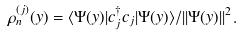<formula> <loc_0><loc_0><loc_500><loc_500>\rho _ { n } ^ { ( j ) } ( y ) = \langle \Psi ( y ) | c _ { j } ^ { \dagger } c _ { j } | \Psi ( y ) \rangle / | | \Psi ( y ) | | ^ { 2 } .</formula> 